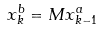<formula> <loc_0><loc_0><loc_500><loc_500>x _ { k } ^ { b } = M x _ { k - 1 } ^ { a }</formula> 